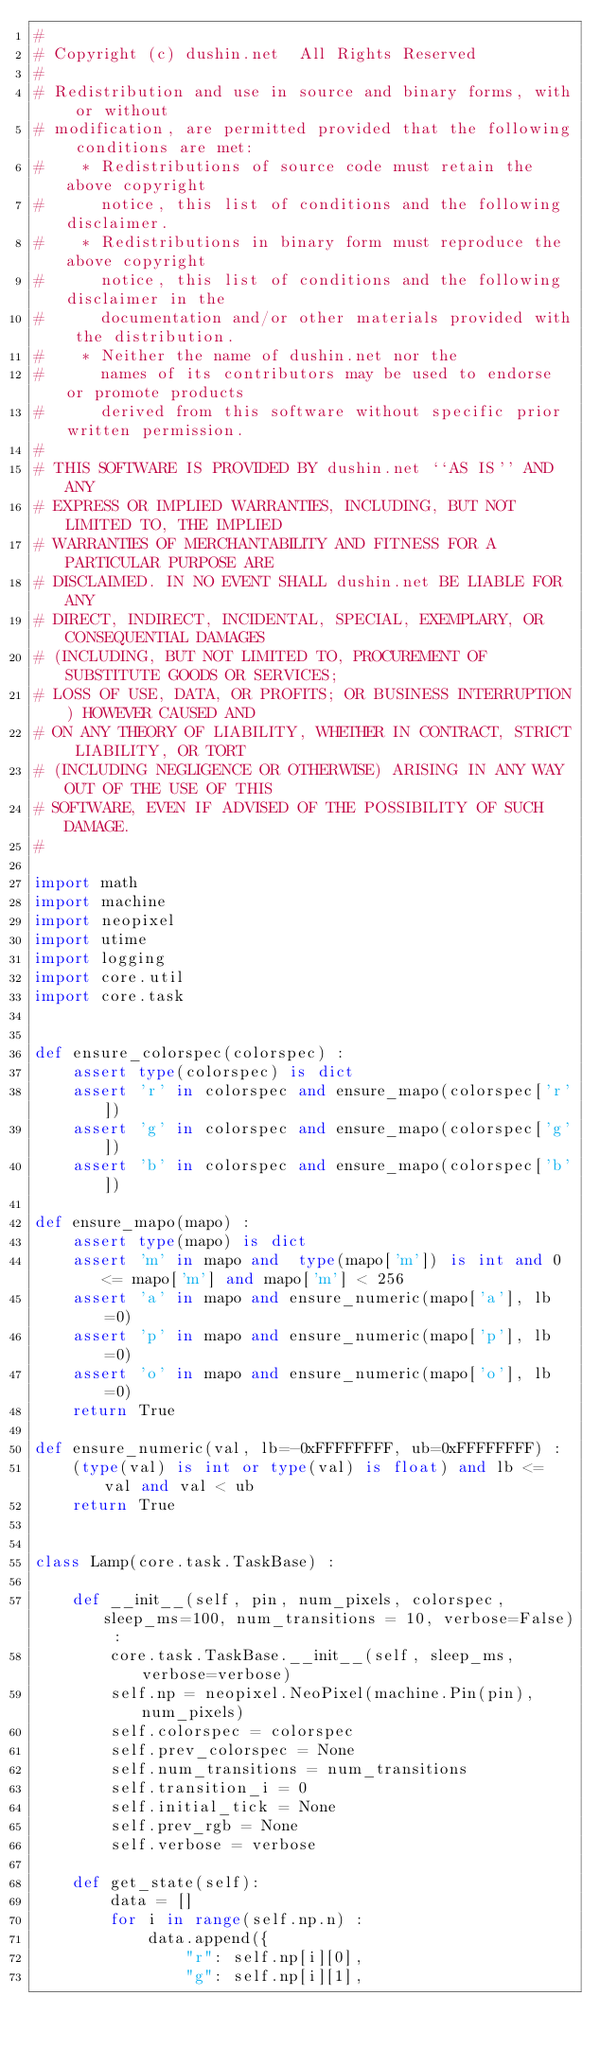Convert code to text. <code><loc_0><loc_0><loc_500><loc_500><_Python_>#
# Copyright (c) dushin.net  All Rights Reserved
#
# Redistribution and use in source and binary forms, with or without
# modification, are permitted provided that the following conditions are met:
#    * Redistributions of source code must retain the above copyright
#      notice, this list of conditions and the following disclaimer.
#    * Redistributions in binary form must reproduce the above copyright
#      notice, this list of conditions and the following disclaimer in the
#      documentation and/or other materials provided with the distribution.
#    * Neither the name of dushin.net nor the
#      names of its contributors may be used to endorse or promote products
#      derived from this software without specific prior written permission.
#
# THIS SOFTWARE IS PROVIDED BY dushin.net ``AS IS'' AND ANY
# EXPRESS OR IMPLIED WARRANTIES, INCLUDING, BUT NOT LIMITED TO, THE IMPLIED
# WARRANTIES OF MERCHANTABILITY AND FITNESS FOR A PARTICULAR PURPOSE ARE
# DISCLAIMED. IN NO EVENT SHALL dushin.net BE LIABLE FOR ANY
# DIRECT, INDIRECT, INCIDENTAL, SPECIAL, EXEMPLARY, OR CONSEQUENTIAL DAMAGES
# (INCLUDING, BUT NOT LIMITED TO, PROCUREMENT OF SUBSTITUTE GOODS OR SERVICES;
# LOSS OF USE, DATA, OR PROFITS; OR BUSINESS INTERRUPTION) HOWEVER CAUSED AND
# ON ANY THEORY OF LIABILITY, WHETHER IN CONTRACT, STRICT LIABILITY, OR TORT
# (INCLUDING NEGLIGENCE OR OTHERWISE) ARISING IN ANY WAY OUT OF THE USE OF THIS
# SOFTWARE, EVEN IF ADVISED OF THE POSSIBILITY OF SUCH DAMAGE.
#

import math
import machine
import neopixel
import utime
import logging
import core.util
import core.task


def ensure_colorspec(colorspec) :
    assert type(colorspec) is dict
    assert 'r' in colorspec and ensure_mapo(colorspec['r'])
    assert 'g' in colorspec and ensure_mapo(colorspec['g'])
    assert 'b' in colorspec and ensure_mapo(colorspec['b'])

def ensure_mapo(mapo) :
    assert type(mapo) is dict
    assert 'm' in mapo and  type(mapo['m']) is int and 0 <= mapo['m'] and mapo['m'] < 256
    assert 'a' in mapo and ensure_numeric(mapo['a'], lb=0)
    assert 'p' in mapo and ensure_numeric(mapo['p'], lb=0)
    assert 'o' in mapo and ensure_numeric(mapo['o'], lb=0)
    return True

def ensure_numeric(val, lb=-0xFFFFFFFF, ub=0xFFFFFFFF) :
    (type(val) is int or type(val) is float) and lb <= val and val < ub
    return True


class Lamp(core.task.TaskBase) :

    def __init__(self, pin, num_pixels, colorspec, sleep_ms=100, num_transitions = 10, verbose=False) :
        core.task.TaskBase.__init__(self, sleep_ms, verbose=verbose)
        self.np = neopixel.NeoPixel(machine.Pin(pin), num_pixels)
        self.colorspec = colorspec
        self.prev_colorspec = None
        self.num_transitions = num_transitions
        self.transition_i = 0
        self.initial_tick = None
        self.prev_rgb = None
        self.verbose = verbose
    
    def get_state(self):
        data = []
        for i in range(self.np.n) :
            data.append({
                "r": self.np[i][0],
                "g": self.np[i][1],</code> 